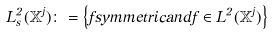Convert formula to latex. <formula><loc_0><loc_0><loc_500><loc_500>L ^ { 2 } _ { s } ( \mathbb { X } ^ { j } ) \colon = \left \{ f s y m m e t r i c a n d f \in L ^ { 2 } ( \mathbb { X } ^ { j } ) \right \}</formula> 